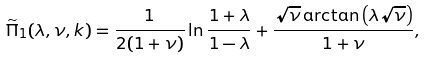<formula> <loc_0><loc_0><loc_500><loc_500>\widetilde { \Pi } _ { 1 } ( \lambda , \nu , k ) = \frac { 1 } { 2 ( 1 + \nu ) } \ln \frac { 1 + \lambda } { 1 - \lambda } + \frac { \sqrt { \nu } \arctan \left ( \lambda \sqrt { \nu } \right ) } { 1 + \nu } ,</formula> 